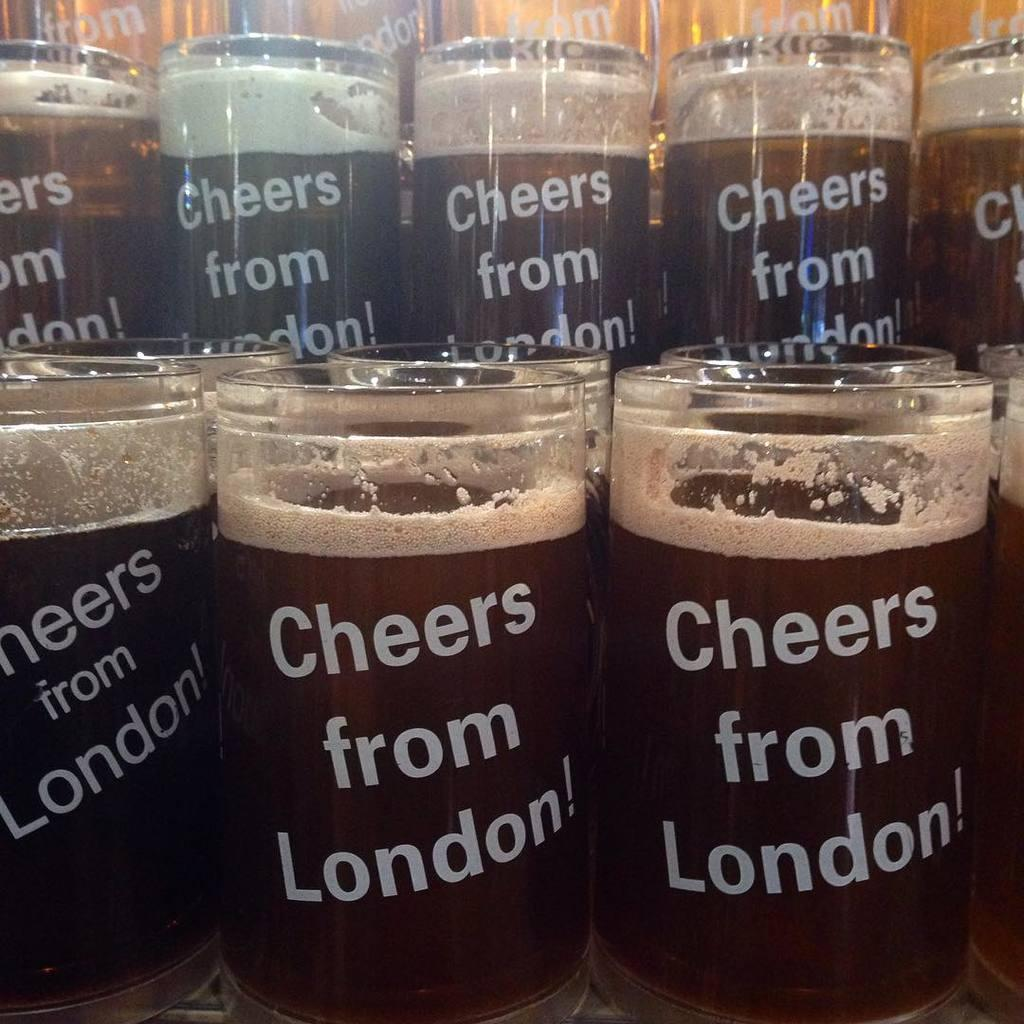What can be found inside the glasses in the image? There are drinks inside the glasses in the image. What additional feature can be observed on the glasses? There is text on the glasses. What type of body of water is visible in the image? There is no body of water present in the image; it features glasses containing drinks with text on them. 